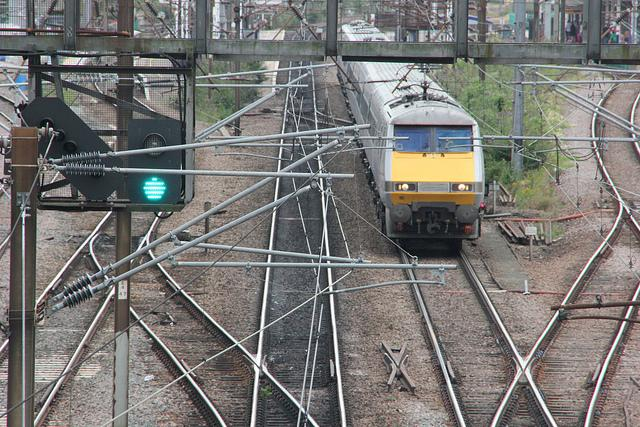The rightmost set of rails leads to which railway structure? train station 